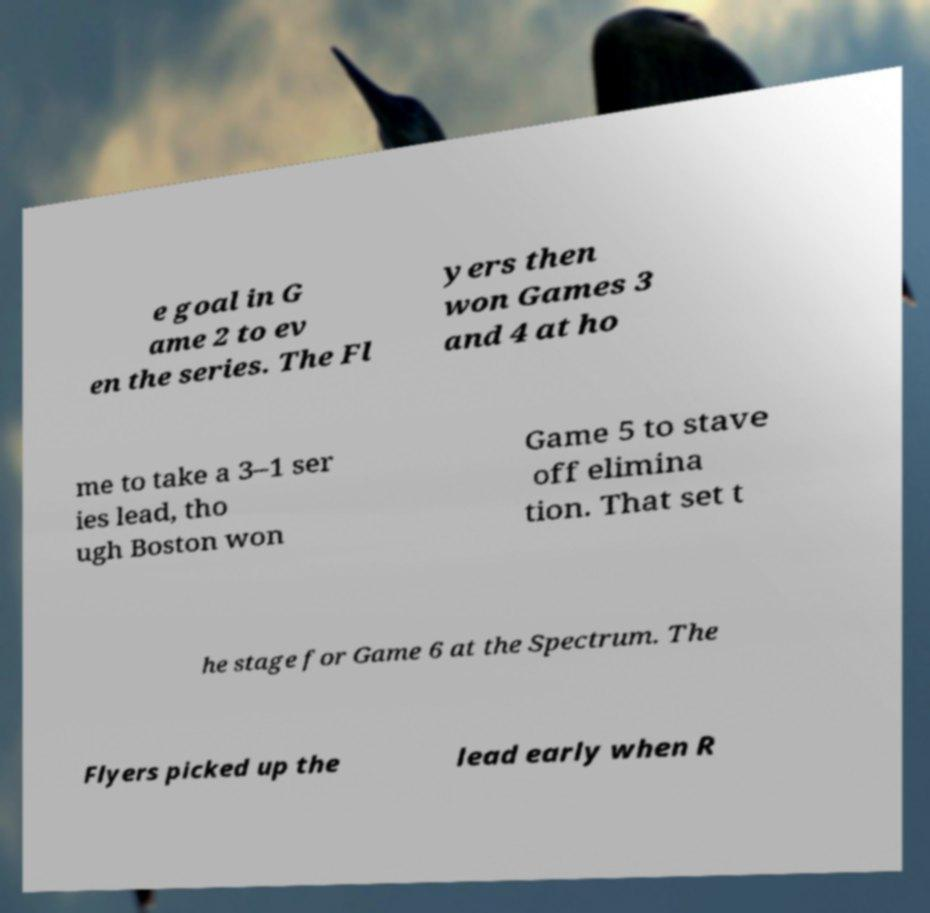Can you accurately transcribe the text from the provided image for me? e goal in G ame 2 to ev en the series. The Fl yers then won Games 3 and 4 at ho me to take a 3–1 ser ies lead, tho ugh Boston won Game 5 to stave off elimina tion. That set t he stage for Game 6 at the Spectrum. The Flyers picked up the lead early when R 